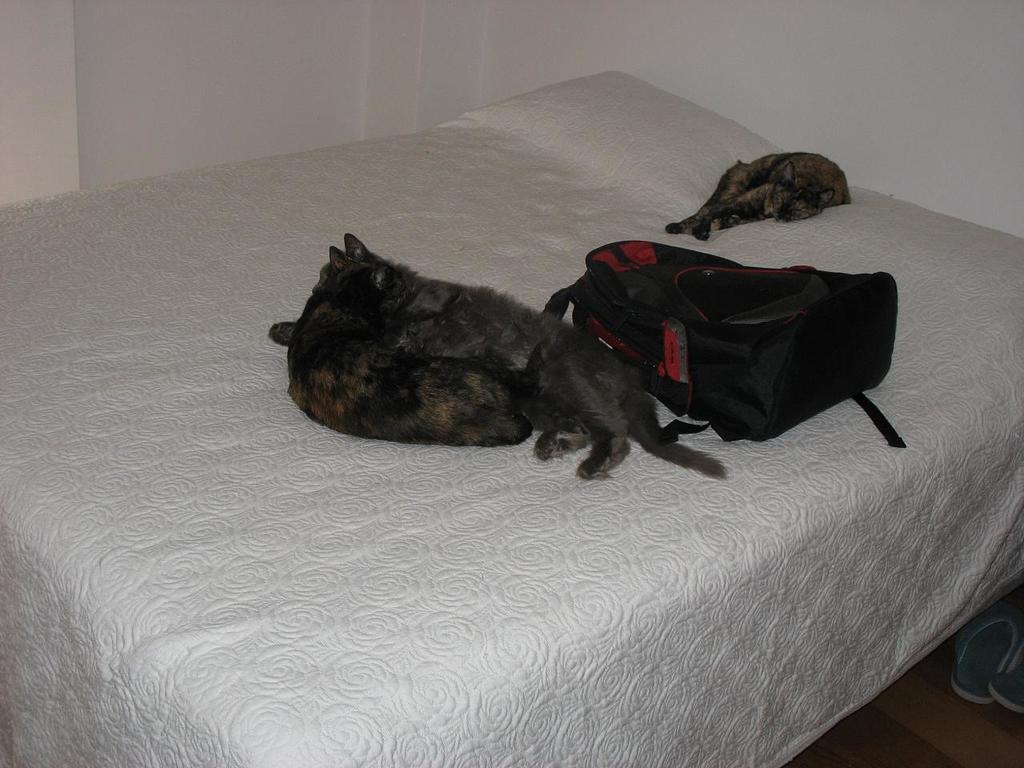How would you summarize this image in a sentence or two? There are three cats and a black bag on a white bed. 